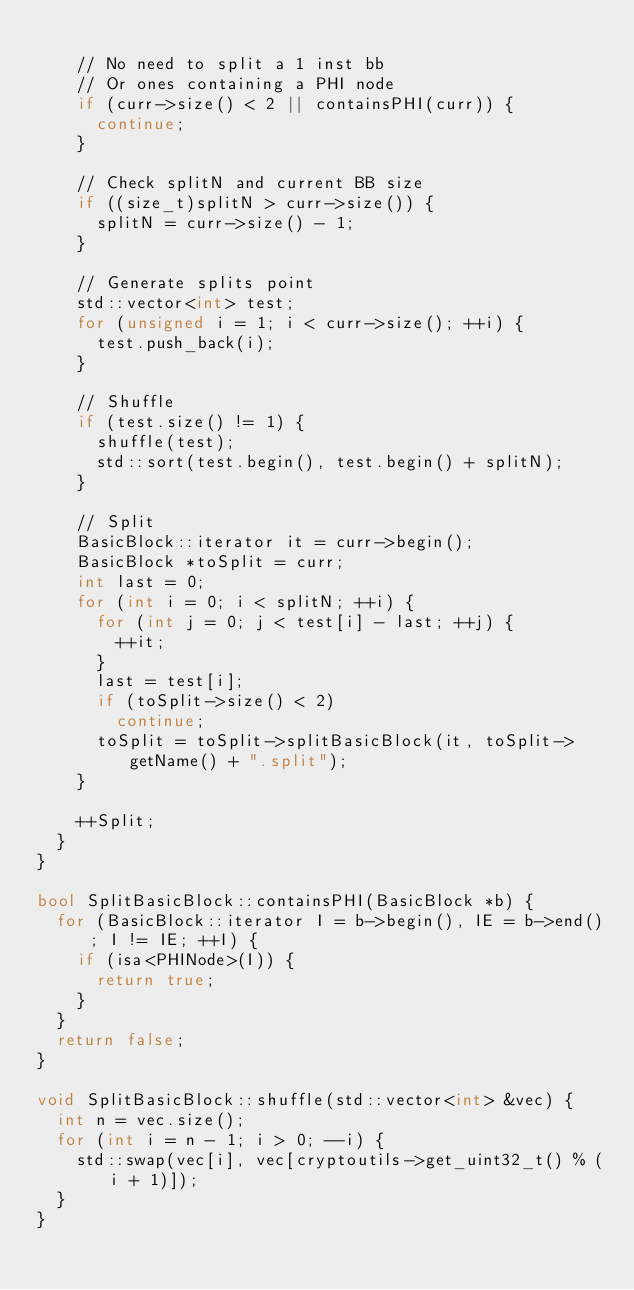Convert code to text. <code><loc_0><loc_0><loc_500><loc_500><_C++_>
    // No need to split a 1 inst bb
    // Or ones containing a PHI node
    if (curr->size() < 2 || containsPHI(curr)) {
      continue;
    }

    // Check splitN and current BB size
    if ((size_t)splitN > curr->size()) {
      splitN = curr->size() - 1;
    }

    // Generate splits point
    std::vector<int> test;
    for (unsigned i = 1; i < curr->size(); ++i) {
      test.push_back(i);
    }

    // Shuffle
    if (test.size() != 1) {
      shuffle(test);
      std::sort(test.begin(), test.begin() + splitN);
    }

    // Split
    BasicBlock::iterator it = curr->begin();
    BasicBlock *toSplit = curr;
    int last = 0;
    for (int i = 0; i < splitN; ++i) {
      for (int j = 0; j < test[i] - last; ++j) {
        ++it;
      }
      last = test[i];
      if (toSplit->size() < 2)
        continue;
      toSplit = toSplit->splitBasicBlock(it, toSplit->getName() + ".split");
    }

    ++Split;
  }
}

bool SplitBasicBlock::containsPHI(BasicBlock *b) {
  for (BasicBlock::iterator I = b->begin(), IE = b->end(); I != IE; ++I) {
    if (isa<PHINode>(I)) {
      return true;
    }
  }
  return false;
}

void SplitBasicBlock::shuffle(std::vector<int> &vec) {
  int n = vec.size();
  for (int i = n - 1; i > 0; --i) {
    std::swap(vec[i], vec[cryptoutils->get_uint32_t() % (i + 1)]);
  }
}
</code> 